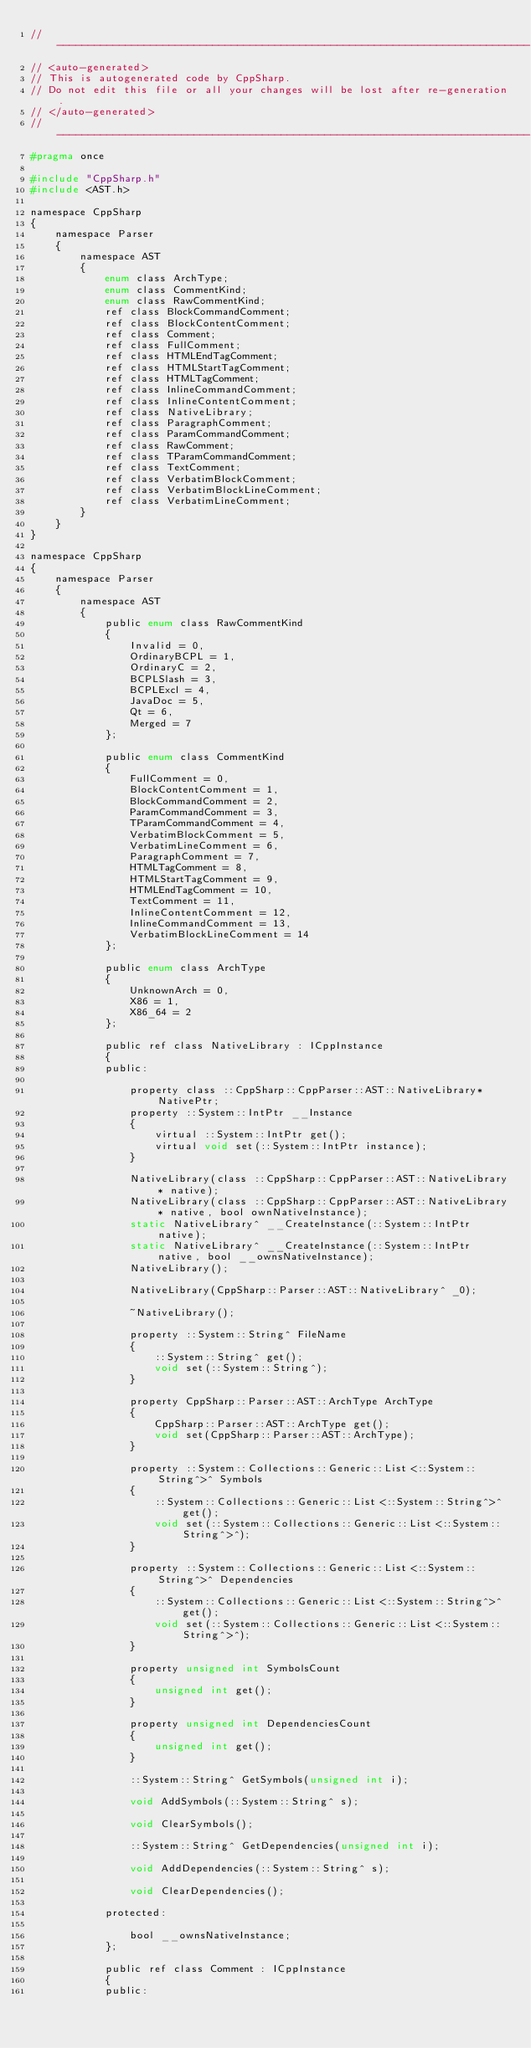Convert code to text. <code><loc_0><loc_0><loc_500><loc_500><_C_>// ----------------------------------------------------------------------------
// <auto-generated>
// This is autogenerated code by CppSharp.
// Do not edit this file or all your changes will be lost after re-generation.
// </auto-generated>
// ----------------------------------------------------------------------------
#pragma once

#include "CppSharp.h"
#include <AST.h>

namespace CppSharp
{
    namespace Parser
    {
        namespace AST
        {
            enum class ArchType;
            enum class CommentKind;
            enum class RawCommentKind;
            ref class BlockCommandComment;
            ref class BlockContentComment;
            ref class Comment;
            ref class FullComment;
            ref class HTMLEndTagComment;
            ref class HTMLStartTagComment;
            ref class HTMLTagComment;
            ref class InlineCommandComment;
            ref class InlineContentComment;
            ref class NativeLibrary;
            ref class ParagraphComment;
            ref class ParamCommandComment;
            ref class RawComment;
            ref class TParamCommandComment;
            ref class TextComment;
            ref class VerbatimBlockComment;
            ref class VerbatimBlockLineComment;
            ref class VerbatimLineComment;
        }
    }
}

namespace CppSharp
{
    namespace Parser
    {
        namespace AST
        {
            public enum class RawCommentKind
            {
                Invalid = 0,
                OrdinaryBCPL = 1,
                OrdinaryC = 2,
                BCPLSlash = 3,
                BCPLExcl = 4,
                JavaDoc = 5,
                Qt = 6,
                Merged = 7
            };

            public enum class CommentKind
            {
                FullComment = 0,
                BlockContentComment = 1,
                BlockCommandComment = 2,
                ParamCommandComment = 3,
                TParamCommandComment = 4,
                VerbatimBlockComment = 5,
                VerbatimLineComment = 6,
                ParagraphComment = 7,
                HTMLTagComment = 8,
                HTMLStartTagComment = 9,
                HTMLEndTagComment = 10,
                TextComment = 11,
                InlineContentComment = 12,
                InlineCommandComment = 13,
                VerbatimBlockLineComment = 14
            };

            public enum class ArchType
            {
                UnknownArch = 0,
                X86 = 1,
                X86_64 = 2
            };

            public ref class NativeLibrary : ICppInstance
            {
            public:

                property class ::CppSharp::CppParser::AST::NativeLibrary* NativePtr;
                property ::System::IntPtr __Instance
                {
                    virtual ::System::IntPtr get();
                    virtual void set(::System::IntPtr instance);
                }

                NativeLibrary(class ::CppSharp::CppParser::AST::NativeLibrary* native);
                NativeLibrary(class ::CppSharp::CppParser::AST::NativeLibrary* native, bool ownNativeInstance);
                static NativeLibrary^ __CreateInstance(::System::IntPtr native);
                static NativeLibrary^ __CreateInstance(::System::IntPtr native, bool __ownsNativeInstance);
                NativeLibrary();

                NativeLibrary(CppSharp::Parser::AST::NativeLibrary^ _0);

                ~NativeLibrary();

                property ::System::String^ FileName
                {
                    ::System::String^ get();
                    void set(::System::String^);
                }

                property CppSharp::Parser::AST::ArchType ArchType
                {
                    CppSharp::Parser::AST::ArchType get();
                    void set(CppSharp::Parser::AST::ArchType);
                }

                property ::System::Collections::Generic::List<::System::String^>^ Symbols
                {
                    ::System::Collections::Generic::List<::System::String^>^ get();
                    void set(::System::Collections::Generic::List<::System::String^>^);
                }

                property ::System::Collections::Generic::List<::System::String^>^ Dependencies
                {
                    ::System::Collections::Generic::List<::System::String^>^ get();
                    void set(::System::Collections::Generic::List<::System::String^>^);
                }

                property unsigned int SymbolsCount
                {
                    unsigned int get();
                }

                property unsigned int DependenciesCount
                {
                    unsigned int get();
                }

                ::System::String^ GetSymbols(unsigned int i);

                void AddSymbols(::System::String^ s);

                void ClearSymbols();

                ::System::String^ GetDependencies(unsigned int i);

                void AddDependencies(::System::String^ s);

                void ClearDependencies();

            protected:

                bool __ownsNativeInstance;
            };

            public ref class Comment : ICppInstance
            {
            public:
</code> 